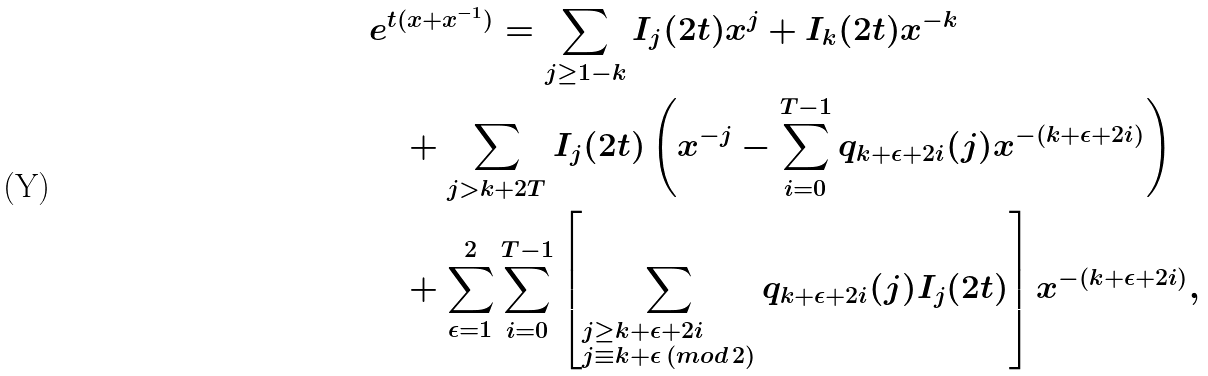Convert formula to latex. <formula><loc_0><loc_0><loc_500><loc_500>& e ^ { t ( x + x ^ { - 1 } ) } = \sum _ { j \geq 1 - k } I _ { j } ( 2 t ) x ^ { j } + I _ { k } ( 2 t ) x ^ { - k } \\ & \quad + \sum _ { j > k + 2 T } I _ { j } ( 2 t ) \left ( x ^ { - j } - \sum _ { i = 0 } ^ { T - 1 } q _ { k + \epsilon + 2 i } ( j ) x ^ { - ( k + \epsilon + 2 i ) } \right ) \\ & \quad + \sum _ { \epsilon = 1 } ^ { 2 } \sum _ { i = 0 } ^ { T - 1 } \left [ \sum _ { \begin{subarray} { c } j \geq k + \epsilon + 2 i \\ j \equiv k + \epsilon \, ( { m o d } \, 2 ) \end{subarray} } q _ { k + \epsilon + 2 i } ( j ) I _ { j } ( 2 t ) \right ] x ^ { - ( k + \epsilon + 2 i ) } ,</formula> 